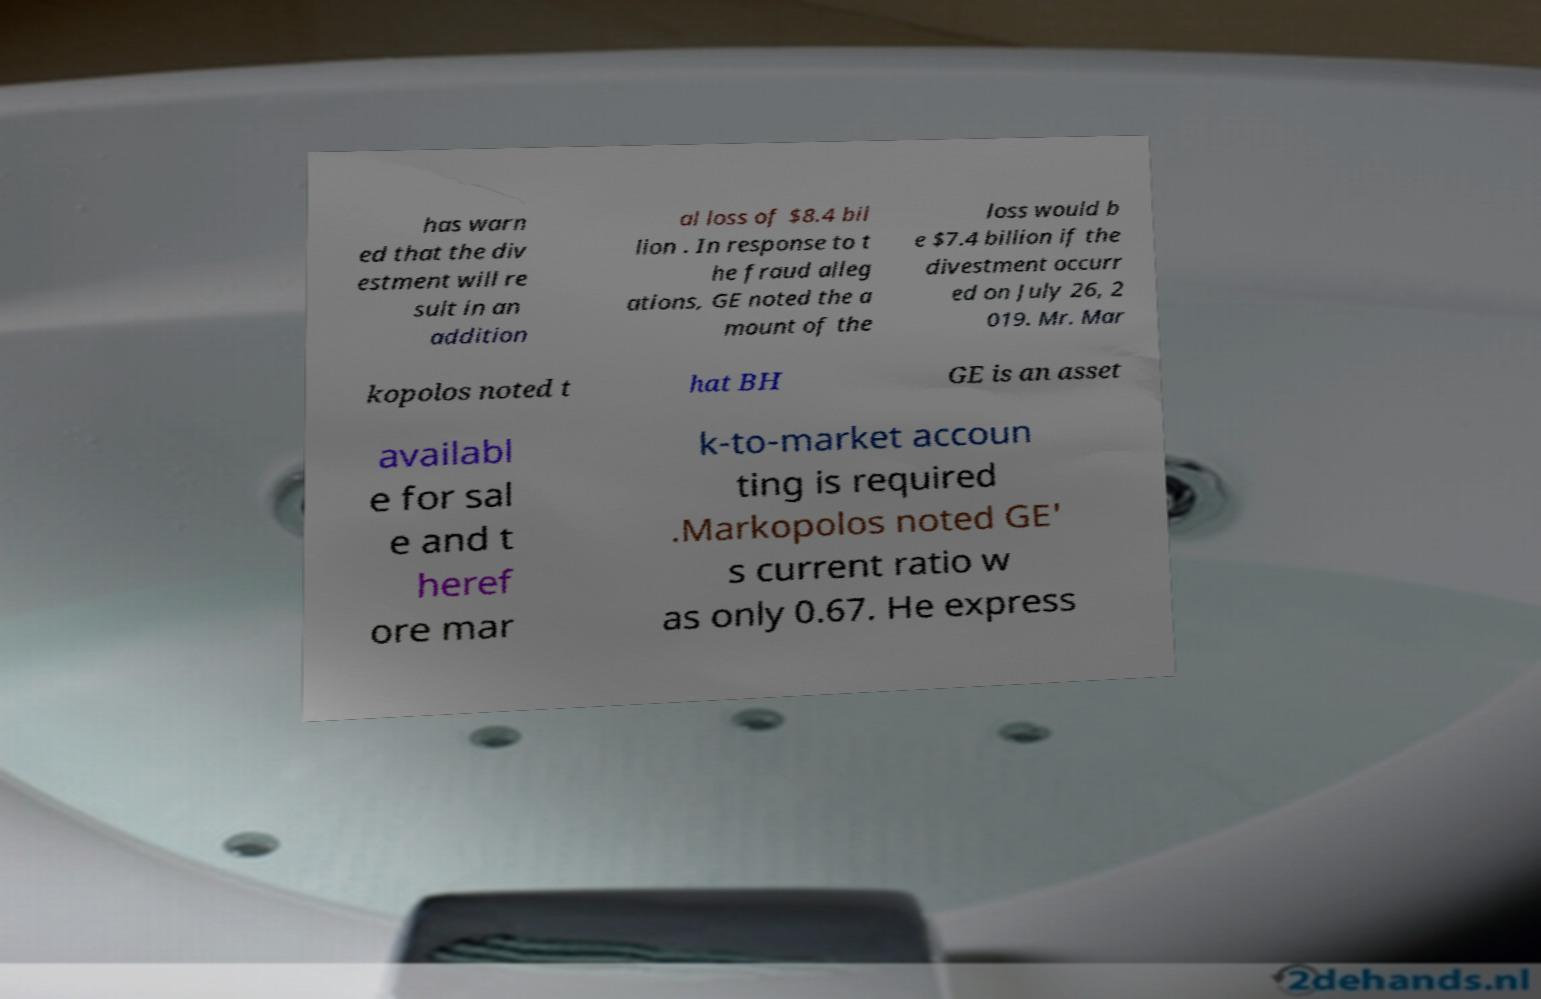Could you extract and type out the text from this image? has warn ed that the div estment will re sult in an addition al loss of $8.4 bil lion . In response to t he fraud alleg ations, GE noted the a mount of the loss would b e $7.4 billion if the divestment occurr ed on July 26, 2 019. Mr. Mar kopolos noted t hat BH GE is an asset availabl e for sal e and t heref ore mar k-to-market accoun ting is required .Markopolos noted GE' s current ratio w as only 0.67. He express 